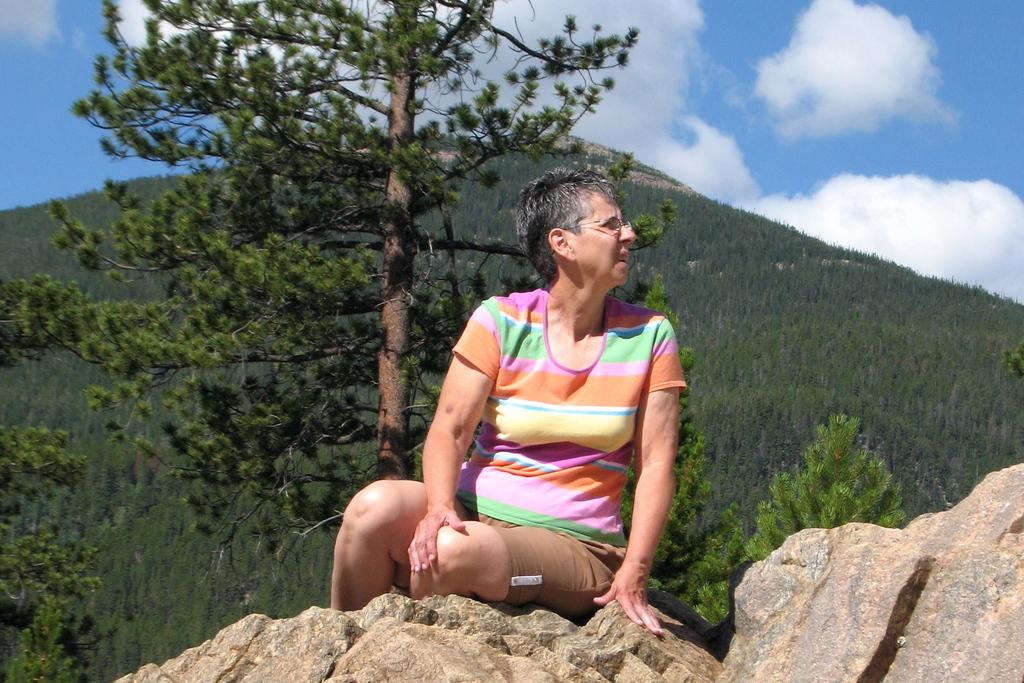Who is present in the image? There is a woman in the image. What is the woman wearing? The woman is wearing clothes and spectacles. Where is the woman sitting? The woman is sitting on a rock. What type of natural environment is visible in the image? There are many trees and a mountain in the image. What is the condition of the sky in the image? The sky is cloudy in the image. Can you see any quivers or caves in the image? There are no quivers or caves present in the image. What type of pear is the woman holding in the image? There is no pear visible in the image. 